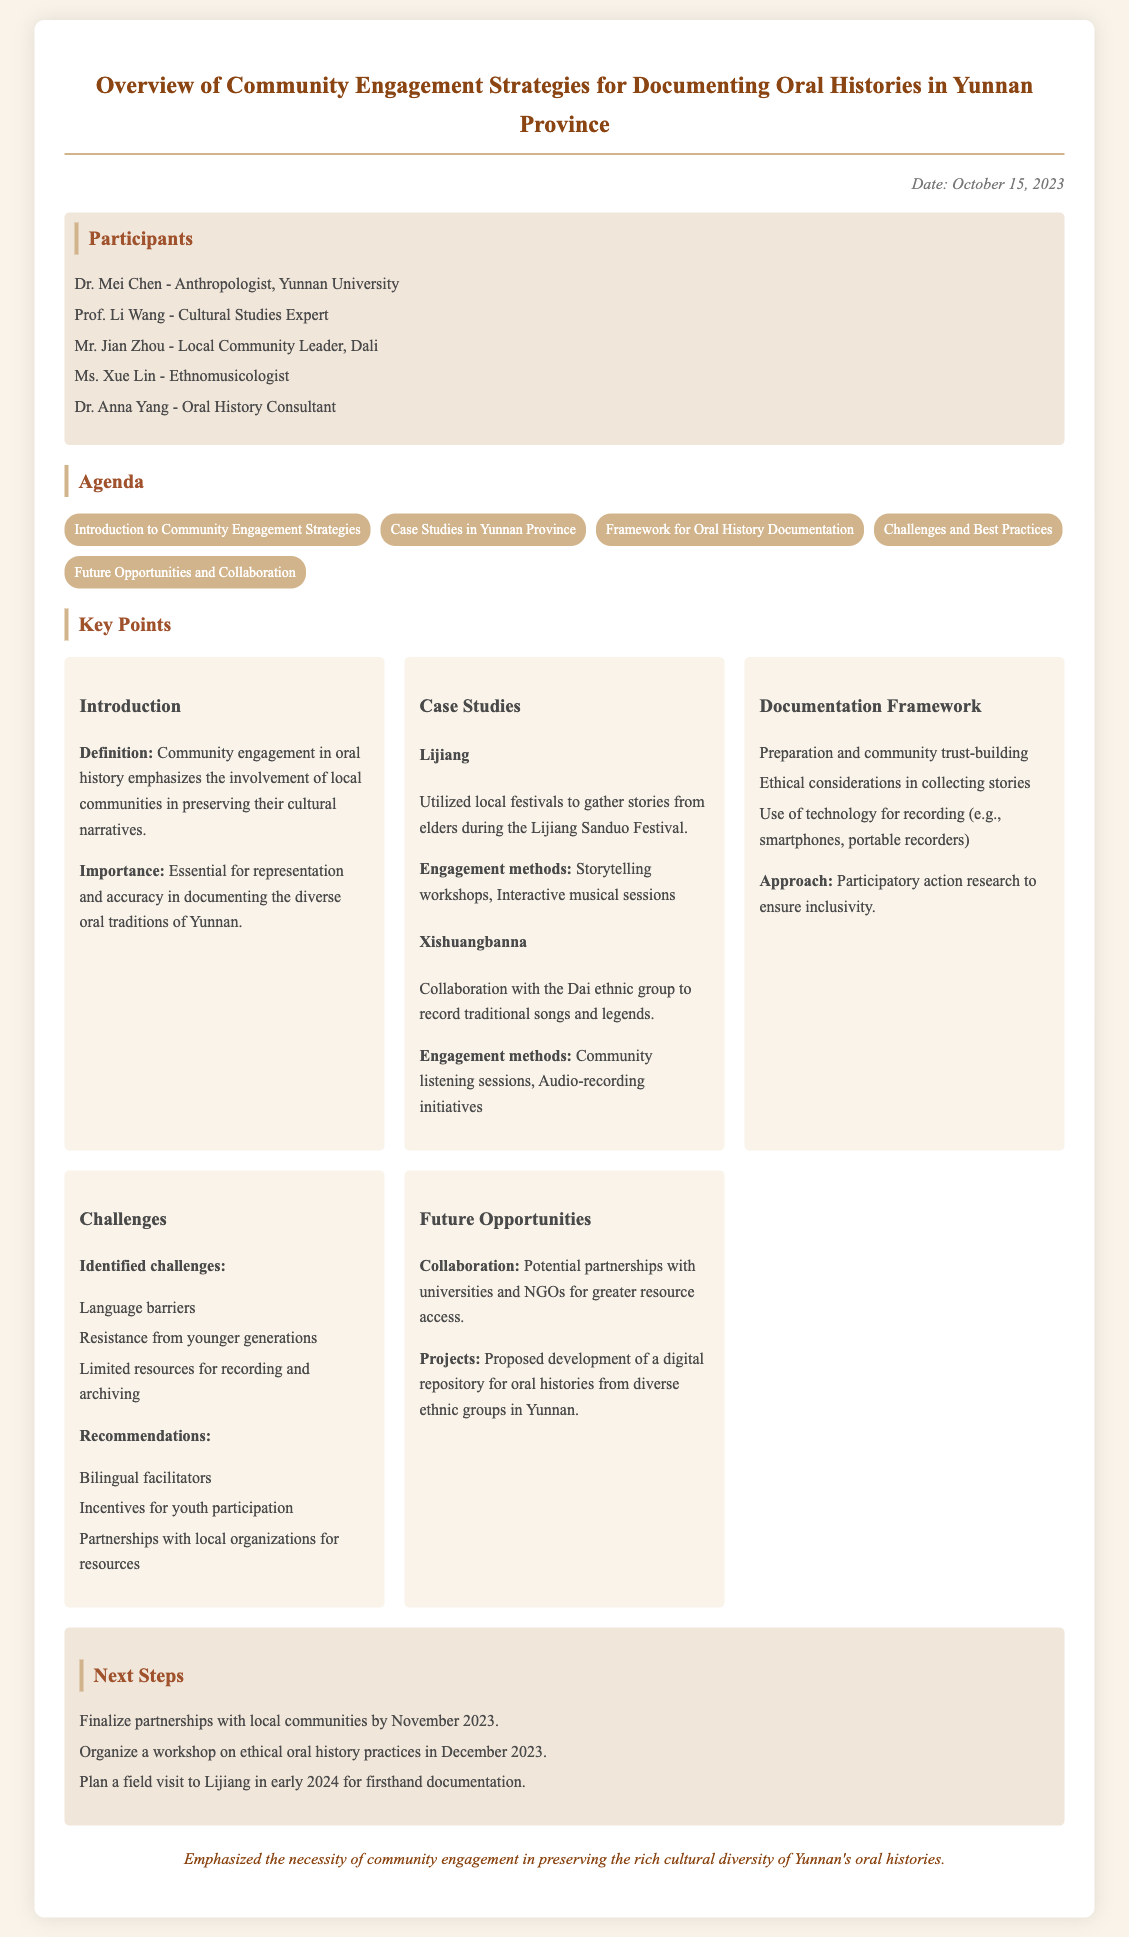What is the date of the meeting? The date of the meeting is mentioned at the top of the document.
Answer: October 15, 2023 Who is the local community leader from Dali? The document lists participants, including a local community leader.
Answer: Mr. Jian Zhou What is one of the key challenges identified? The document provides a list of challenges in the challenges section.
Answer: Language barriers What engagement method was used in Lijiang? The document describes specific methods used for community engagement in Lijiang.
Answer: Storytelling workshops What is one potential project mentioned for the future? The document outlines future opportunities, including potential projects.
Answer: Digital repository for oral histories How many participants are listed in the document? The document lists all participants in a section, and counting them gives the total.
Answer: Five What ethical aspect is mentioned in the documentation framework? The document specifies aspects of ethical considerations in collecting stories.
Answer: Ethical considerations in collecting stories What are the next steps to be completed by November 2023? The document outlines specific steps planned for future actions.
Answer: Finalize partnerships with local communities 